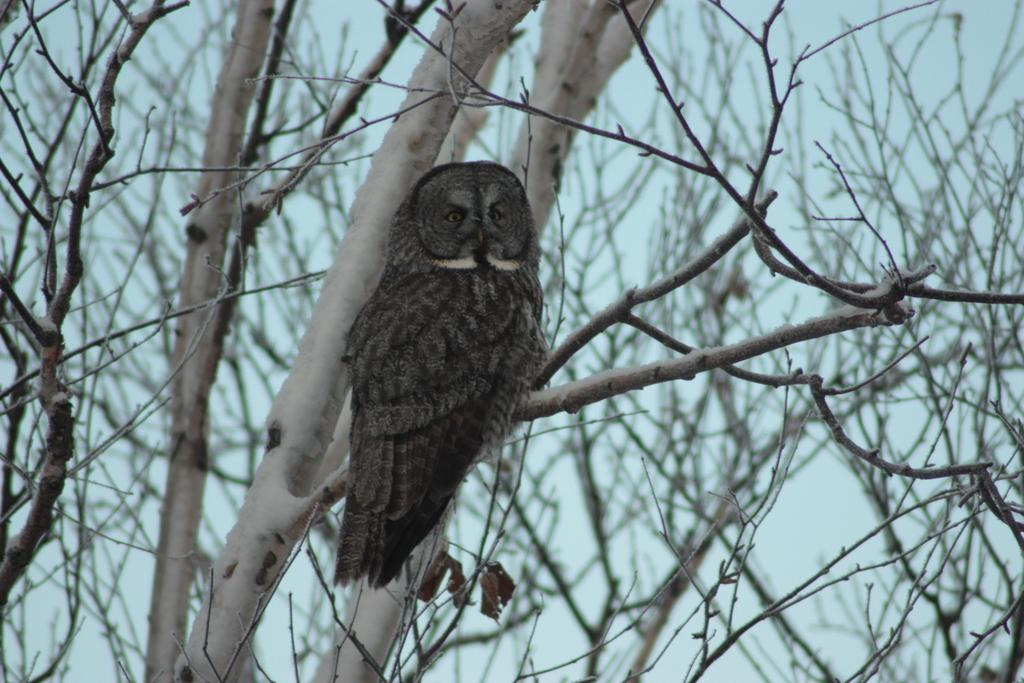What type of animal is in the image? There is a bird in the image. What colors can be seen on the bird? The bird has brown and black colors. What is the bird standing on? The bird is standing on a dried tree. What color is the sky in the background? The sky in the background is light blue. How many eggs are visible on the floor in the image? There are no eggs visible in the image; it features a bird standing on a dried tree with a light blue sky in the background. 